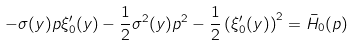<formula> <loc_0><loc_0><loc_500><loc_500>- \sigma ( y ) p \xi _ { 0 } ^ { \prime } ( y ) - \frac { 1 } { 2 } \sigma ^ { 2 } ( y ) p ^ { 2 } - \frac { 1 } { 2 } \left ( \xi _ { 0 } ^ { \prime } ( y ) \right ) ^ { 2 } = \bar { H } _ { 0 } ( p )</formula> 